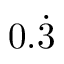Convert formula to latex. <formula><loc_0><loc_0><loc_500><loc_500>0 . { \dot { 3 } }</formula> 